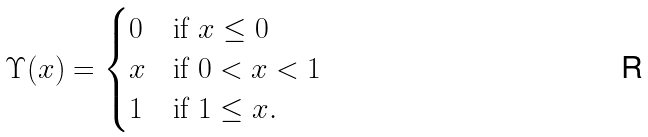<formula> <loc_0><loc_0><loc_500><loc_500>\Upsilon ( x ) = \begin{cases} 0 & \text {if } x \leq 0 \\ x & \text {if } 0 < x < 1 \\ 1 & \text {if } 1 \leq x . \end{cases}</formula> 